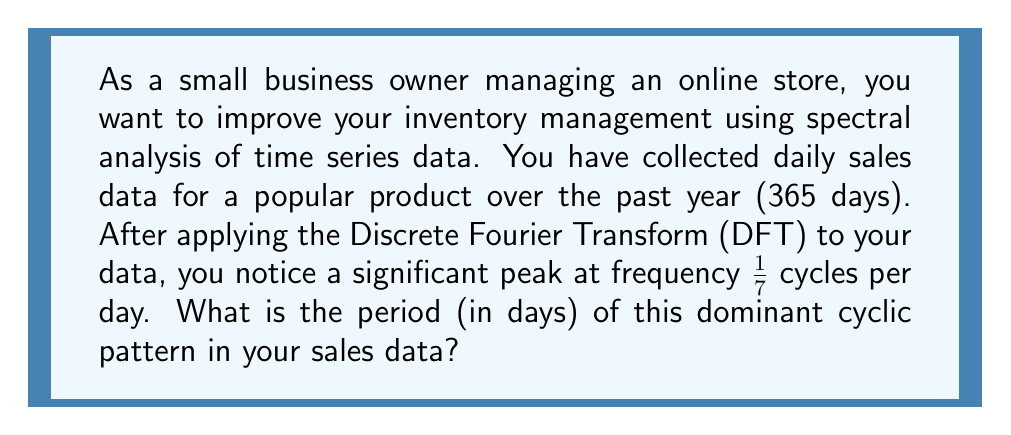Help me with this question. To find the period of the cyclic pattern, we need to follow these steps:

1. Recall that frequency ($f$) and period ($T$) are inversely related:

   $$T = \frac{1}{f}$$

2. We are given that the significant peak occurs at a frequency of $\frac{1}{7}$ cycles per day.

3. Substituting this into our equation:

   $$T = \frac{1}{\frac{1}{7}} = 7$$

4. Therefore, the period of the dominant cyclic pattern is 7 days.

This result suggests a weekly pattern in your sales data, which is common in retail due to weekend shopping habits. Understanding this pattern can help you optimize your inventory management by ensuring you have sufficient stock for peak sales days.
Answer: 7 days 